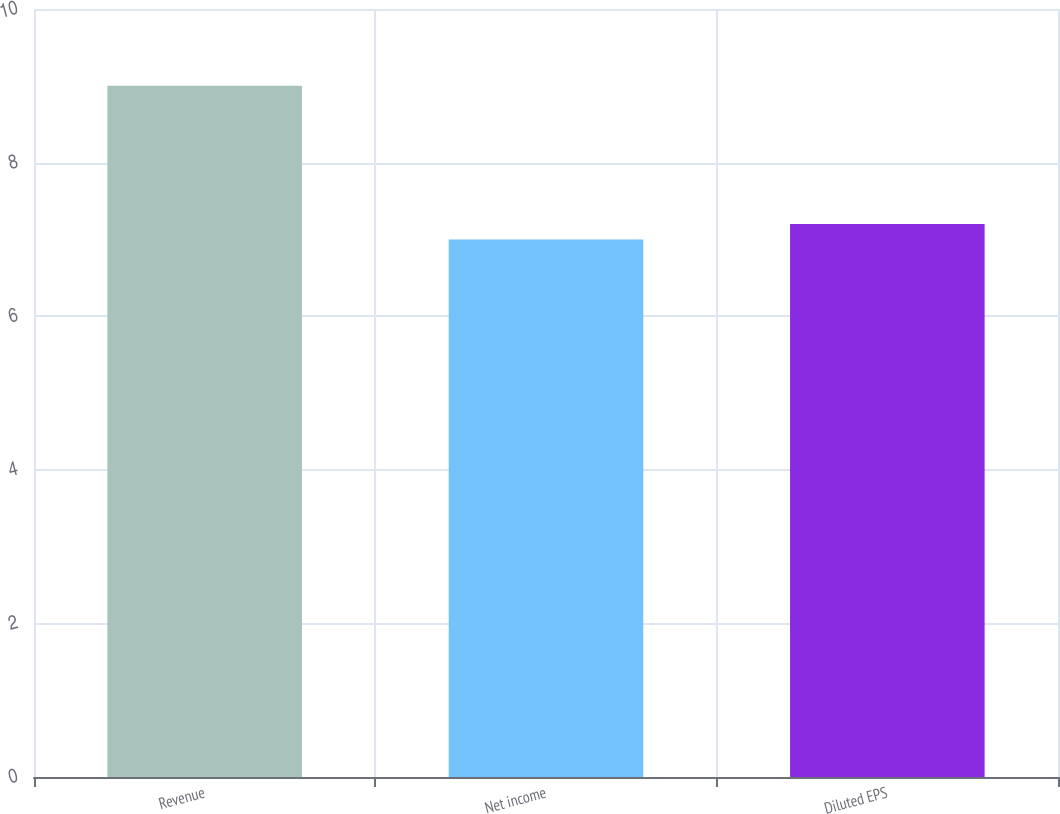Convert chart. <chart><loc_0><loc_0><loc_500><loc_500><bar_chart><fcel>Revenue<fcel>Net income<fcel>Diluted EPS<nl><fcel>9<fcel>7<fcel>7.2<nl></chart> 